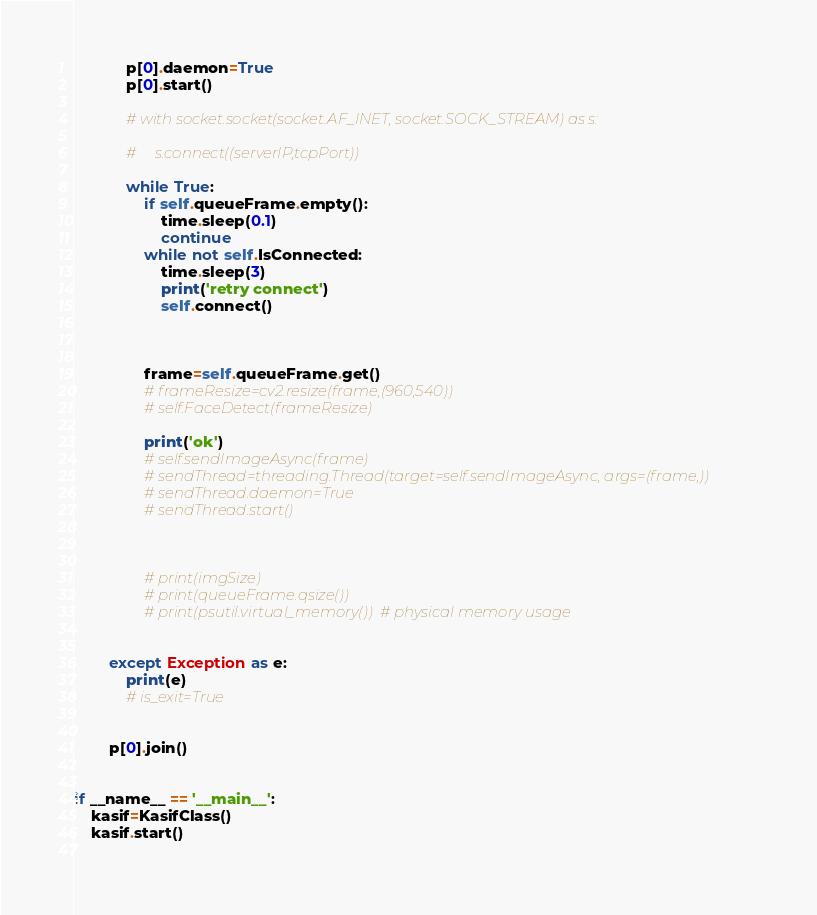<code> <loc_0><loc_0><loc_500><loc_500><_Python_>            p[0].daemon=True
            p[0].start()

            # with socket.socket(socket.AF_INET, socket.SOCK_STREAM) as s:

            #     s.connect((serverIP,tcpPort))    

            while True:
                if self.queueFrame.empty():
                    time.sleep(0.1)
                    continue
                while not self.IsConnected:
                    time.sleep(3)
                    print('retry connect')
                    self.connect()                

 
                
                frame=self.queueFrame.get()
                # frameResize=cv2.resize(frame,(960,540))
                # self.FaceDetect(frameResize)

                print('ok')
                # self.sendImageAsync(frame)
                # sendThread=threading.Thread(target=self.sendImageAsync, args=(frame,))
                # sendThread.daemon=True
                # sendThread.start()


                
                # print(imgSize)
                # print(queueFrame.qsize())
                # print(psutil.virtual_memory())  # physical memory usage
                

        except Exception as e:
            print(e)
            # is_exit=True


        p[0].join()


if __name__ == '__main__':
    kasif=KasifClass()
    kasif.start()
    
</code> 